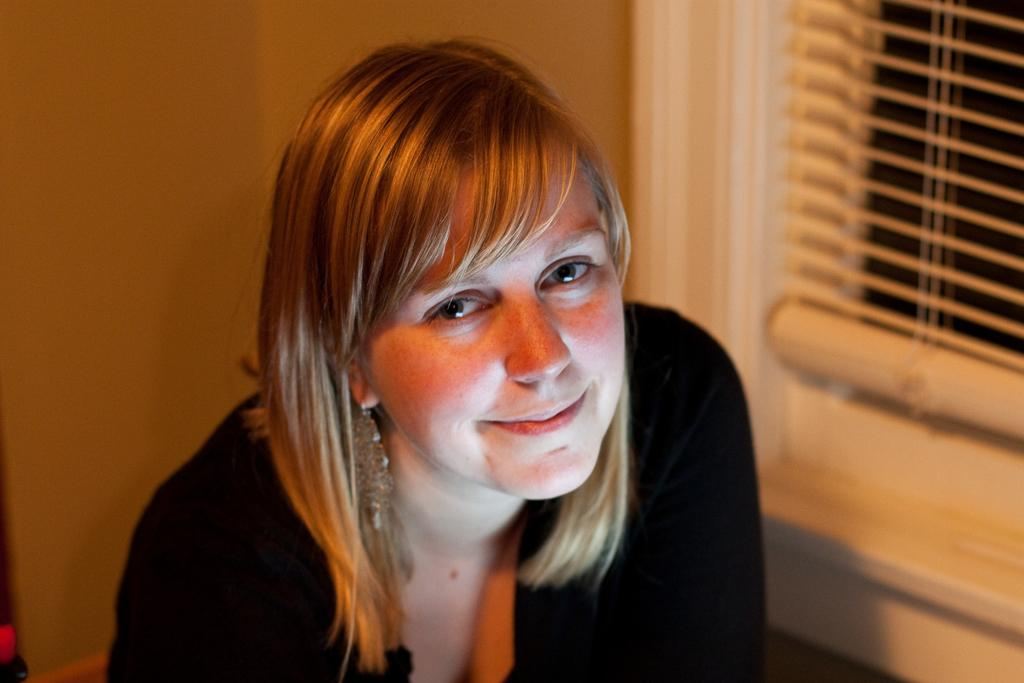Who is present in the image? There is a lady in the image. What is the lady wearing? The lady is wearing a black dress. What can be seen on the right side of the image? There is a window on the right side of the image. What is visible in the background of the image? There is a wall in the background of the image. What type of bell can be heard ringing in the image? There is no bell present in the image, and therefore no sound can be heard. 